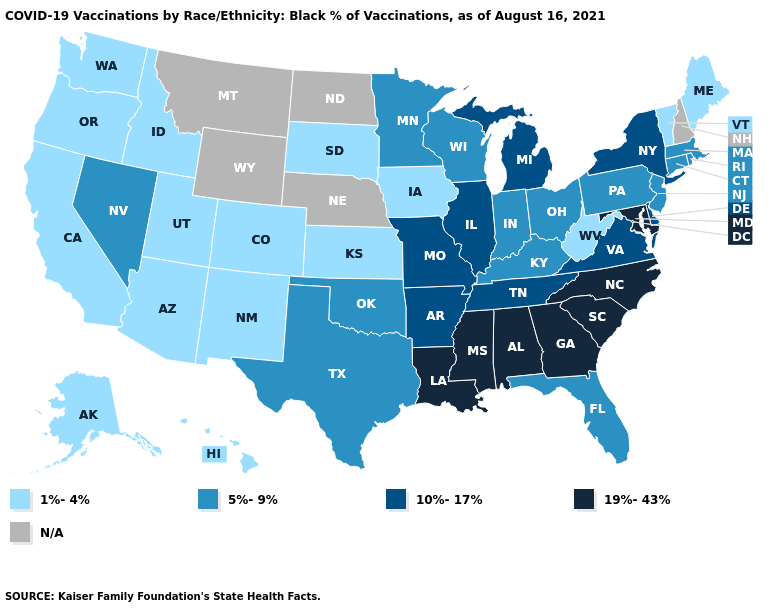Name the states that have a value in the range 10%-17%?
Answer briefly. Arkansas, Delaware, Illinois, Michigan, Missouri, New York, Tennessee, Virginia. Does Michigan have the highest value in the USA?
Quick response, please. No. Which states have the lowest value in the USA?
Be succinct. Alaska, Arizona, California, Colorado, Hawaii, Idaho, Iowa, Kansas, Maine, New Mexico, Oregon, South Dakota, Utah, Vermont, Washington, West Virginia. Does Tennessee have the lowest value in the South?
Quick response, please. No. Which states have the lowest value in the MidWest?
Give a very brief answer. Iowa, Kansas, South Dakota. Does Georgia have the highest value in the USA?
Keep it brief. Yes. What is the highest value in the USA?
Write a very short answer. 19%-43%. Name the states that have a value in the range N/A?
Quick response, please. Montana, Nebraska, New Hampshire, North Dakota, Wyoming. Is the legend a continuous bar?
Be succinct. No. What is the highest value in states that border New Mexico?
Quick response, please. 5%-9%. Name the states that have a value in the range 19%-43%?
Concise answer only. Alabama, Georgia, Louisiana, Maryland, Mississippi, North Carolina, South Carolina. What is the highest value in states that border Connecticut?
Give a very brief answer. 10%-17%. 